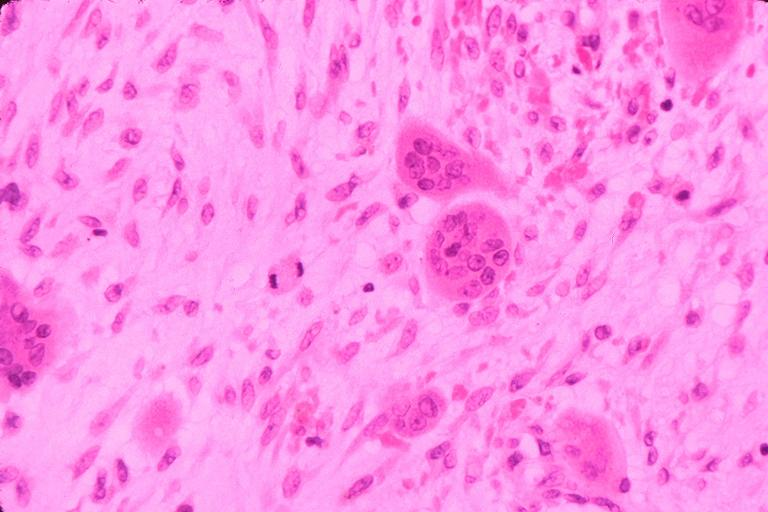what is present?
Answer the question using a single word or phrase. Oral 